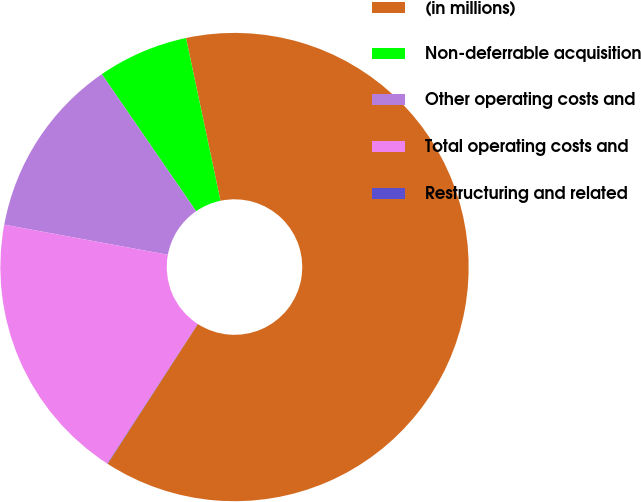Convert chart to OTSL. <chart><loc_0><loc_0><loc_500><loc_500><pie_chart><fcel>(in millions)<fcel>Non-deferrable acquisition<fcel>Other operating costs and<fcel>Total operating costs and<fcel>Restructuring and related<nl><fcel>62.43%<fcel>6.27%<fcel>12.51%<fcel>18.75%<fcel>0.03%<nl></chart> 